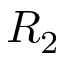<formula> <loc_0><loc_0><loc_500><loc_500>R _ { 2 }</formula> 